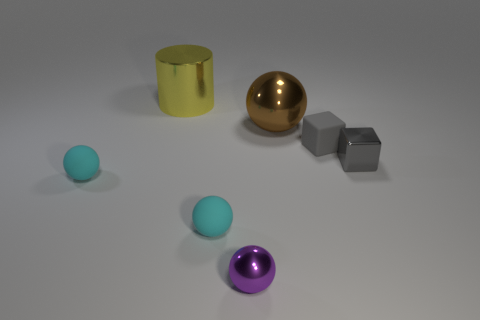Subtract all big metal balls. How many balls are left? 3 Subtract all purple balls. How many balls are left? 3 Subtract all red spheres. Subtract all yellow blocks. How many spheres are left? 4 Add 1 small gray matte cubes. How many objects exist? 8 Subtract all cylinders. How many objects are left? 6 Add 5 purple shiny balls. How many purple shiny balls exist? 6 Subtract 0 green cylinders. How many objects are left? 7 Subtract all large brown rubber cylinders. Subtract all brown things. How many objects are left? 6 Add 2 small things. How many small things are left? 7 